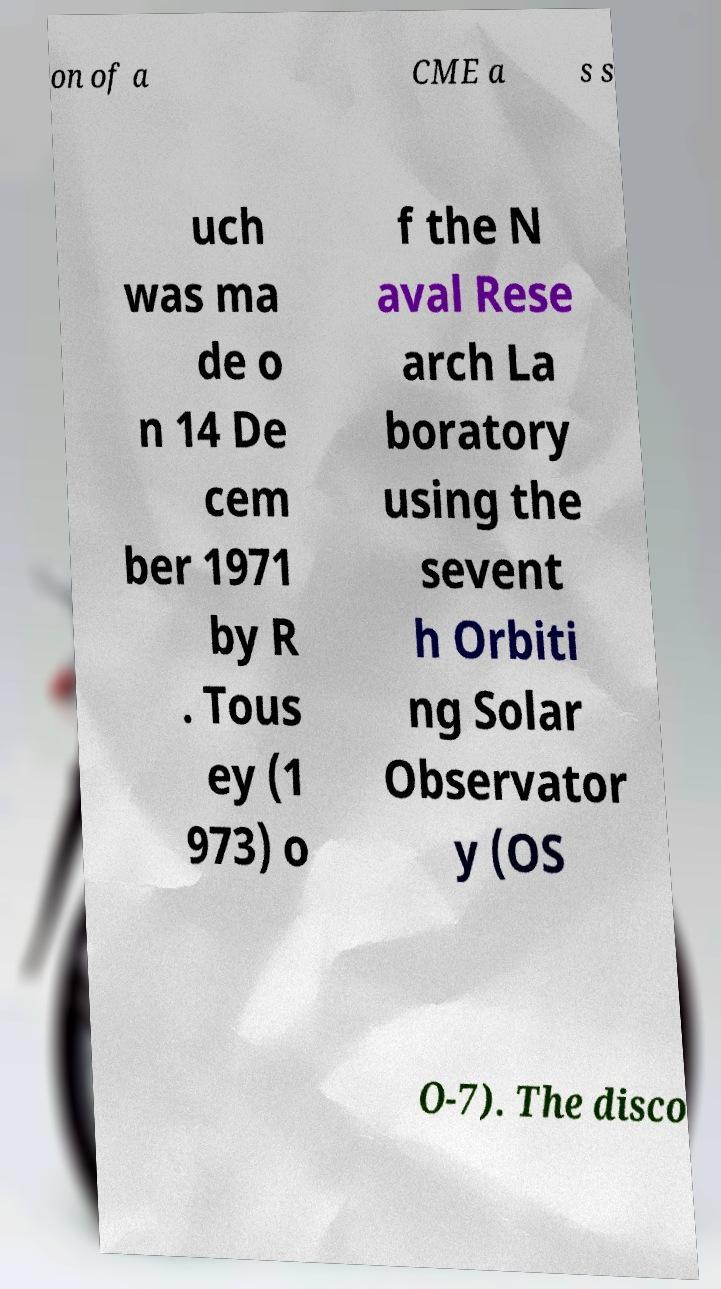For documentation purposes, I need the text within this image transcribed. Could you provide that? on of a CME a s s uch was ma de o n 14 De cem ber 1971 by R . Tous ey (1 973) o f the N aval Rese arch La boratory using the sevent h Orbiti ng Solar Observator y (OS O-7). The disco 